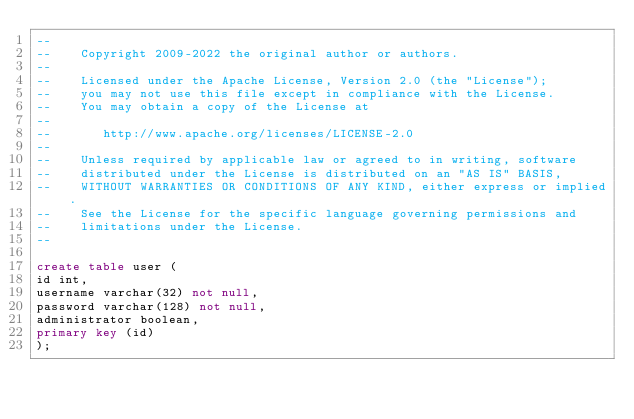<code> <loc_0><loc_0><loc_500><loc_500><_SQL_>--
--    Copyright 2009-2022 the original author or authors.
--
--    Licensed under the Apache License, Version 2.0 (the "License");
--    you may not use this file except in compliance with the License.
--    You may obtain a copy of the License at
--
--       http://www.apache.org/licenses/LICENSE-2.0
--
--    Unless required by applicable law or agreed to in writing, software
--    distributed under the License is distributed on an "AS IS" BASIS,
--    WITHOUT WARRANTIES OR CONDITIONS OF ANY KIND, either express or implied.
--    See the License for the specific language governing permissions and
--    limitations under the License.
--

create table user (
id int,
username varchar(32) not null,
password varchar(128) not null,
administrator boolean,
primary key (id)
);
</code> 